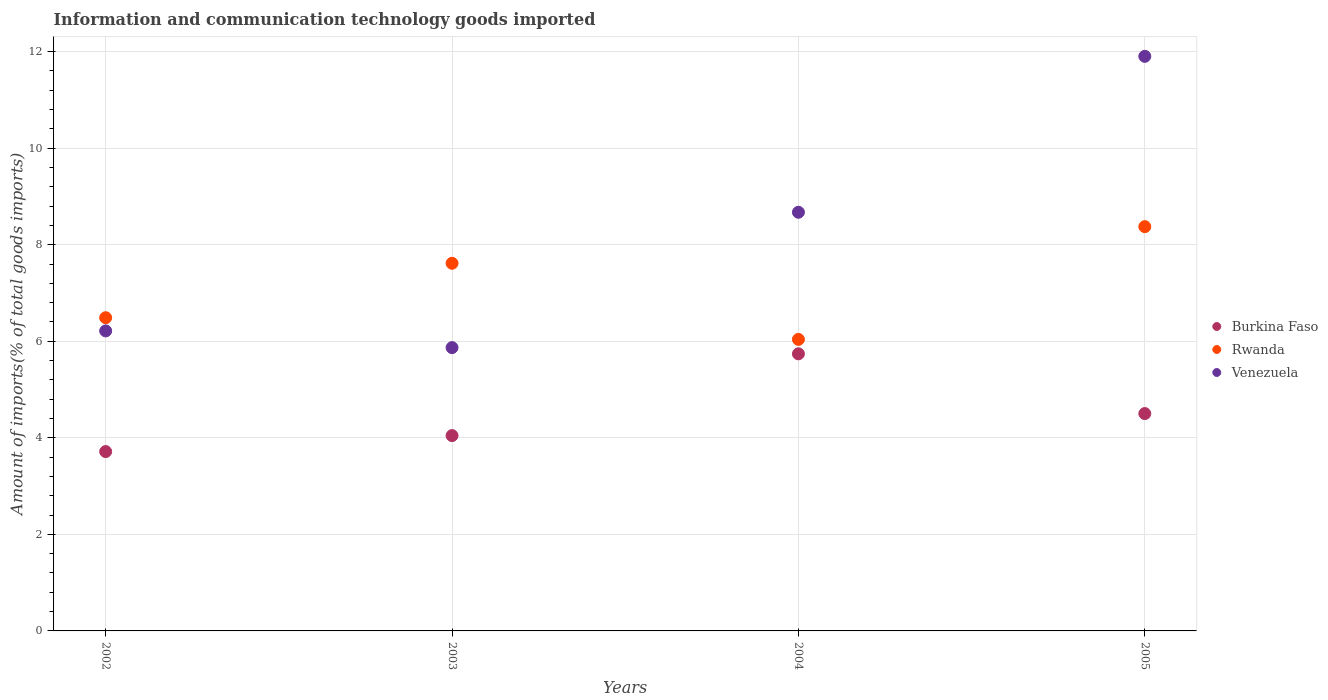Is the number of dotlines equal to the number of legend labels?
Offer a terse response. Yes. What is the amount of goods imported in Burkina Faso in 2002?
Offer a very short reply. 3.72. Across all years, what is the maximum amount of goods imported in Venezuela?
Give a very brief answer. 11.9. Across all years, what is the minimum amount of goods imported in Venezuela?
Provide a short and direct response. 5.87. In which year was the amount of goods imported in Burkina Faso minimum?
Ensure brevity in your answer.  2002. What is the total amount of goods imported in Venezuela in the graph?
Provide a short and direct response. 32.66. What is the difference between the amount of goods imported in Burkina Faso in 2004 and that in 2005?
Offer a terse response. 1.24. What is the difference between the amount of goods imported in Rwanda in 2002 and the amount of goods imported in Burkina Faso in 2005?
Ensure brevity in your answer.  1.99. What is the average amount of goods imported in Venezuela per year?
Your answer should be compact. 8.17. In the year 2005, what is the difference between the amount of goods imported in Burkina Faso and amount of goods imported in Rwanda?
Offer a terse response. -3.87. What is the ratio of the amount of goods imported in Venezuela in 2002 to that in 2003?
Offer a very short reply. 1.06. Is the difference between the amount of goods imported in Burkina Faso in 2004 and 2005 greater than the difference between the amount of goods imported in Rwanda in 2004 and 2005?
Keep it short and to the point. Yes. What is the difference between the highest and the second highest amount of goods imported in Venezuela?
Provide a short and direct response. 3.23. What is the difference between the highest and the lowest amount of goods imported in Venezuela?
Offer a terse response. 6.03. In how many years, is the amount of goods imported in Burkina Faso greater than the average amount of goods imported in Burkina Faso taken over all years?
Ensure brevity in your answer.  2. Does the amount of goods imported in Burkina Faso monotonically increase over the years?
Provide a short and direct response. No. How many dotlines are there?
Offer a very short reply. 3. Are the values on the major ticks of Y-axis written in scientific E-notation?
Give a very brief answer. No. Does the graph contain any zero values?
Offer a terse response. No. Does the graph contain grids?
Provide a succinct answer. Yes. Where does the legend appear in the graph?
Provide a succinct answer. Center right. How are the legend labels stacked?
Provide a short and direct response. Vertical. What is the title of the graph?
Provide a short and direct response. Information and communication technology goods imported. Does "Bosnia and Herzegovina" appear as one of the legend labels in the graph?
Make the answer very short. No. What is the label or title of the X-axis?
Provide a succinct answer. Years. What is the label or title of the Y-axis?
Provide a succinct answer. Amount of imports(% of total goods imports). What is the Amount of imports(% of total goods imports) in Burkina Faso in 2002?
Offer a very short reply. 3.72. What is the Amount of imports(% of total goods imports) in Rwanda in 2002?
Make the answer very short. 6.49. What is the Amount of imports(% of total goods imports) of Venezuela in 2002?
Offer a terse response. 6.22. What is the Amount of imports(% of total goods imports) of Burkina Faso in 2003?
Your response must be concise. 4.05. What is the Amount of imports(% of total goods imports) of Rwanda in 2003?
Make the answer very short. 7.62. What is the Amount of imports(% of total goods imports) in Venezuela in 2003?
Your answer should be compact. 5.87. What is the Amount of imports(% of total goods imports) in Burkina Faso in 2004?
Your answer should be compact. 5.74. What is the Amount of imports(% of total goods imports) of Rwanda in 2004?
Keep it short and to the point. 6.04. What is the Amount of imports(% of total goods imports) in Venezuela in 2004?
Offer a very short reply. 8.67. What is the Amount of imports(% of total goods imports) in Burkina Faso in 2005?
Offer a very short reply. 4.5. What is the Amount of imports(% of total goods imports) of Rwanda in 2005?
Your answer should be very brief. 8.38. What is the Amount of imports(% of total goods imports) in Venezuela in 2005?
Provide a succinct answer. 11.9. Across all years, what is the maximum Amount of imports(% of total goods imports) in Burkina Faso?
Make the answer very short. 5.74. Across all years, what is the maximum Amount of imports(% of total goods imports) in Rwanda?
Offer a terse response. 8.38. Across all years, what is the maximum Amount of imports(% of total goods imports) in Venezuela?
Your answer should be very brief. 11.9. Across all years, what is the minimum Amount of imports(% of total goods imports) in Burkina Faso?
Keep it short and to the point. 3.72. Across all years, what is the minimum Amount of imports(% of total goods imports) in Rwanda?
Provide a succinct answer. 6.04. Across all years, what is the minimum Amount of imports(% of total goods imports) of Venezuela?
Your response must be concise. 5.87. What is the total Amount of imports(% of total goods imports) in Burkina Faso in the graph?
Your answer should be compact. 18.01. What is the total Amount of imports(% of total goods imports) of Rwanda in the graph?
Provide a short and direct response. 28.52. What is the total Amount of imports(% of total goods imports) of Venezuela in the graph?
Ensure brevity in your answer.  32.66. What is the difference between the Amount of imports(% of total goods imports) of Burkina Faso in 2002 and that in 2003?
Your answer should be compact. -0.33. What is the difference between the Amount of imports(% of total goods imports) of Rwanda in 2002 and that in 2003?
Your answer should be compact. -1.13. What is the difference between the Amount of imports(% of total goods imports) of Venezuela in 2002 and that in 2003?
Offer a terse response. 0.35. What is the difference between the Amount of imports(% of total goods imports) in Burkina Faso in 2002 and that in 2004?
Provide a succinct answer. -2.03. What is the difference between the Amount of imports(% of total goods imports) in Rwanda in 2002 and that in 2004?
Keep it short and to the point. 0.45. What is the difference between the Amount of imports(% of total goods imports) of Venezuela in 2002 and that in 2004?
Keep it short and to the point. -2.46. What is the difference between the Amount of imports(% of total goods imports) of Burkina Faso in 2002 and that in 2005?
Your answer should be very brief. -0.79. What is the difference between the Amount of imports(% of total goods imports) of Rwanda in 2002 and that in 2005?
Keep it short and to the point. -1.89. What is the difference between the Amount of imports(% of total goods imports) of Venezuela in 2002 and that in 2005?
Offer a terse response. -5.69. What is the difference between the Amount of imports(% of total goods imports) in Burkina Faso in 2003 and that in 2004?
Make the answer very short. -1.69. What is the difference between the Amount of imports(% of total goods imports) in Rwanda in 2003 and that in 2004?
Offer a very short reply. 1.58. What is the difference between the Amount of imports(% of total goods imports) in Venezuela in 2003 and that in 2004?
Provide a succinct answer. -2.8. What is the difference between the Amount of imports(% of total goods imports) of Burkina Faso in 2003 and that in 2005?
Offer a very short reply. -0.46. What is the difference between the Amount of imports(% of total goods imports) in Rwanda in 2003 and that in 2005?
Offer a very short reply. -0.76. What is the difference between the Amount of imports(% of total goods imports) in Venezuela in 2003 and that in 2005?
Your response must be concise. -6.03. What is the difference between the Amount of imports(% of total goods imports) of Burkina Faso in 2004 and that in 2005?
Provide a short and direct response. 1.24. What is the difference between the Amount of imports(% of total goods imports) in Rwanda in 2004 and that in 2005?
Keep it short and to the point. -2.34. What is the difference between the Amount of imports(% of total goods imports) in Venezuela in 2004 and that in 2005?
Your answer should be compact. -3.23. What is the difference between the Amount of imports(% of total goods imports) of Burkina Faso in 2002 and the Amount of imports(% of total goods imports) of Rwanda in 2003?
Keep it short and to the point. -3.9. What is the difference between the Amount of imports(% of total goods imports) of Burkina Faso in 2002 and the Amount of imports(% of total goods imports) of Venezuela in 2003?
Your answer should be compact. -2.15. What is the difference between the Amount of imports(% of total goods imports) in Rwanda in 2002 and the Amount of imports(% of total goods imports) in Venezuela in 2003?
Give a very brief answer. 0.62. What is the difference between the Amount of imports(% of total goods imports) in Burkina Faso in 2002 and the Amount of imports(% of total goods imports) in Rwanda in 2004?
Keep it short and to the point. -2.32. What is the difference between the Amount of imports(% of total goods imports) in Burkina Faso in 2002 and the Amount of imports(% of total goods imports) in Venezuela in 2004?
Ensure brevity in your answer.  -4.96. What is the difference between the Amount of imports(% of total goods imports) of Rwanda in 2002 and the Amount of imports(% of total goods imports) of Venezuela in 2004?
Keep it short and to the point. -2.18. What is the difference between the Amount of imports(% of total goods imports) of Burkina Faso in 2002 and the Amount of imports(% of total goods imports) of Rwanda in 2005?
Keep it short and to the point. -4.66. What is the difference between the Amount of imports(% of total goods imports) of Burkina Faso in 2002 and the Amount of imports(% of total goods imports) of Venezuela in 2005?
Give a very brief answer. -8.19. What is the difference between the Amount of imports(% of total goods imports) of Rwanda in 2002 and the Amount of imports(% of total goods imports) of Venezuela in 2005?
Ensure brevity in your answer.  -5.41. What is the difference between the Amount of imports(% of total goods imports) of Burkina Faso in 2003 and the Amount of imports(% of total goods imports) of Rwanda in 2004?
Offer a very short reply. -1.99. What is the difference between the Amount of imports(% of total goods imports) in Burkina Faso in 2003 and the Amount of imports(% of total goods imports) in Venezuela in 2004?
Provide a succinct answer. -4.63. What is the difference between the Amount of imports(% of total goods imports) of Rwanda in 2003 and the Amount of imports(% of total goods imports) of Venezuela in 2004?
Keep it short and to the point. -1.06. What is the difference between the Amount of imports(% of total goods imports) of Burkina Faso in 2003 and the Amount of imports(% of total goods imports) of Rwanda in 2005?
Your answer should be compact. -4.33. What is the difference between the Amount of imports(% of total goods imports) of Burkina Faso in 2003 and the Amount of imports(% of total goods imports) of Venezuela in 2005?
Your answer should be compact. -7.86. What is the difference between the Amount of imports(% of total goods imports) in Rwanda in 2003 and the Amount of imports(% of total goods imports) in Venezuela in 2005?
Ensure brevity in your answer.  -4.29. What is the difference between the Amount of imports(% of total goods imports) in Burkina Faso in 2004 and the Amount of imports(% of total goods imports) in Rwanda in 2005?
Provide a succinct answer. -2.63. What is the difference between the Amount of imports(% of total goods imports) in Burkina Faso in 2004 and the Amount of imports(% of total goods imports) in Venezuela in 2005?
Offer a terse response. -6.16. What is the difference between the Amount of imports(% of total goods imports) of Rwanda in 2004 and the Amount of imports(% of total goods imports) of Venezuela in 2005?
Offer a very short reply. -5.86. What is the average Amount of imports(% of total goods imports) of Burkina Faso per year?
Offer a very short reply. 4.5. What is the average Amount of imports(% of total goods imports) of Rwanda per year?
Offer a very short reply. 7.13. What is the average Amount of imports(% of total goods imports) in Venezuela per year?
Offer a very short reply. 8.17. In the year 2002, what is the difference between the Amount of imports(% of total goods imports) in Burkina Faso and Amount of imports(% of total goods imports) in Rwanda?
Make the answer very short. -2.77. In the year 2002, what is the difference between the Amount of imports(% of total goods imports) in Burkina Faso and Amount of imports(% of total goods imports) in Venezuela?
Keep it short and to the point. -2.5. In the year 2002, what is the difference between the Amount of imports(% of total goods imports) of Rwanda and Amount of imports(% of total goods imports) of Venezuela?
Give a very brief answer. 0.27. In the year 2003, what is the difference between the Amount of imports(% of total goods imports) in Burkina Faso and Amount of imports(% of total goods imports) in Rwanda?
Your answer should be very brief. -3.57. In the year 2003, what is the difference between the Amount of imports(% of total goods imports) in Burkina Faso and Amount of imports(% of total goods imports) in Venezuela?
Make the answer very short. -1.82. In the year 2003, what is the difference between the Amount of imports(% of total goods imports) of Rwanda and Amount of imports(% of total goods imports) of Venezuela?
Offer a terse response. 1.75. In the year 2004, what is the difference between the Amount of imports(% of total goods imports) of Burkina Faso and Amount of imports(% of total goods imports) of Rwanda?
Your response must be concise. -0.3. In the year 2004, what is the difference between the Amount of imports(% of total goods imports) in Burkina Faso and Amount of imports(% of total goods imports) in Venezuela?
Make the answer very short. -2.93. In the year 2004, what is the difference between the Amount of imports(% of total goods imports) in Rwanda and Amount of imports(% of total goods imports) in Venezuela?
Provide a short and direct response. -2.63. In the year 2005, what is the difference between the Amount of imports(% of total goods imports) of Burkina Faso and Amount of imports(% of total goods imports) of Rwanda?
Your response must be concise. -3.87. In the year 2005, what is the difference between the Amount of imports(% of total goods imports) in Burkina Faso and Amount of imports(% of total goods imports) in Venezuela?
Make the answer very short. -7.4. In the year 2005, what is the difference between the Amount of imports(% of total goods imports) in Rwanda and Amount of imports(% of total goods imports) in Venezuela?
Offer a very short reply. -3.53. What is the ratio of the Amount of imports(% of total goods imports) of Burkina Faso in 2002 to that in 2003?
Give a very brief answer. 0.92. What is the ratio of the Amount of imports(% of total goods imports) in Rwanda in 2002 to that in 2003?
Provide a short and direct response. 0.85. What is the ratio of the Amount of imports(% of total goods imports) in Venezuela in 2002 to that in 2003?
Your answer should be compact. 1.06. What is the ratio of the Amount of imports(% of total goods imports) of Burkina Faso in 2002 to that in 2004?
Offer a very short reply. 0.65. What is the ratio of the Amount of imports(% of total goods imports) in Rwanda in 2002 to that in 2004?
Ensure brevity in your answer.  1.07. What is the ratio of the Amount of imports(% of total goods imports) of Venezuela in 2002 to that in 2004?
Give a very brief answer. 0.72. What is the ratio of the Amount of imports(% of total goods imports) of Burkina Faso in 2002 to that in 2005?
Provide a short and direct response. 0.83. What is the ratio of the Amount of imports(% of total goods imports) of Rwanda in 2002 to that in 2005?
Offer a terse response. 0.77. What is the ratio of the Amount of imports(% of total goods imports) of Venezuela in 2002 to that in 2005?
Your answer should be compact. 0.52. What is the ratio of the Amount of imports(% of total goods imports) of Burkina Faso in 2003 to that in 2004?
Give a very brief answer. 0.7. What is the ratio of the Amount of imports(% of total goods imports) in Rwanda in 2003 to that in 2004?
Make the answer very short. 1.26. What is the ratio of the Amount of imports(% of total goods imports) in Venezuela in 2003 to that in 2004?
Provide a short and direct response. 0.68. What is the ratio of the Amount of imports(% of total goods imports) of Burkina Faso in 2003 to that in 2005?
Offer a terse response. 0.9. What is the ratio of the Amount of imports(% of total goods imports) of Rwanda in 2003 to that in 2005?
Give a very brief answer. 0.91. What is the ratio of the Amount of imports(% of total goods imports) of Venezuela in 2003 to that in 2005?
Provide a succinct answer. 0.49. What is the ratio of the Amount of imports(% of total goods imports) of Burkina Faso in 2004 to that in 2005?
Ensure brevity in your answer.  1.27. What is the ratio of the Amount of imports(% of total goods imports) of Rwanda in 2004 to that in 2005?
Keep it short and to the point. 0.72. What is the ratio of the Amount of imports(% of total goods imports) of Venezuela in 2004 to that in 2005?
Make the answer very short. 0.73. What is the difference between the highest and the second highest Amount of imports(% of total goods imports) in Burkina Faso?
Provide a succinct answer. 1.24. What is the difference between the highest and the second highest Amount of imports(% of total goods imports) in Rwanda?
Your response must be concise. 0.76. What is the difference between the highest and the second highest Amount of imports(% of total goods imports) of Venezuela?
Your response must be concise. 3.23. What is the difference between the highest and the lowest Amount of imports(% of total goods imports) in Burkina Faso?
Keep it short and to the point. 2.03. What is the difference between the highest and the lowest Amount of imports(% of total goods imports) in Rwanda?
Make the answer very short. 2.34. What is the difference between the highest and the lowest Amount of imports(% of total goods imports) of Venezuela?
Provide a short and direct response. 6.03. 